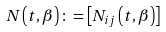Convert formula to latex. <formula><loc_0><loc_0><loc_500><loc_500>N \left ( t , \beta \right ) \colon = \left [ N _ { i j } \left ( t , \beta \right ) \right ]</formula> 